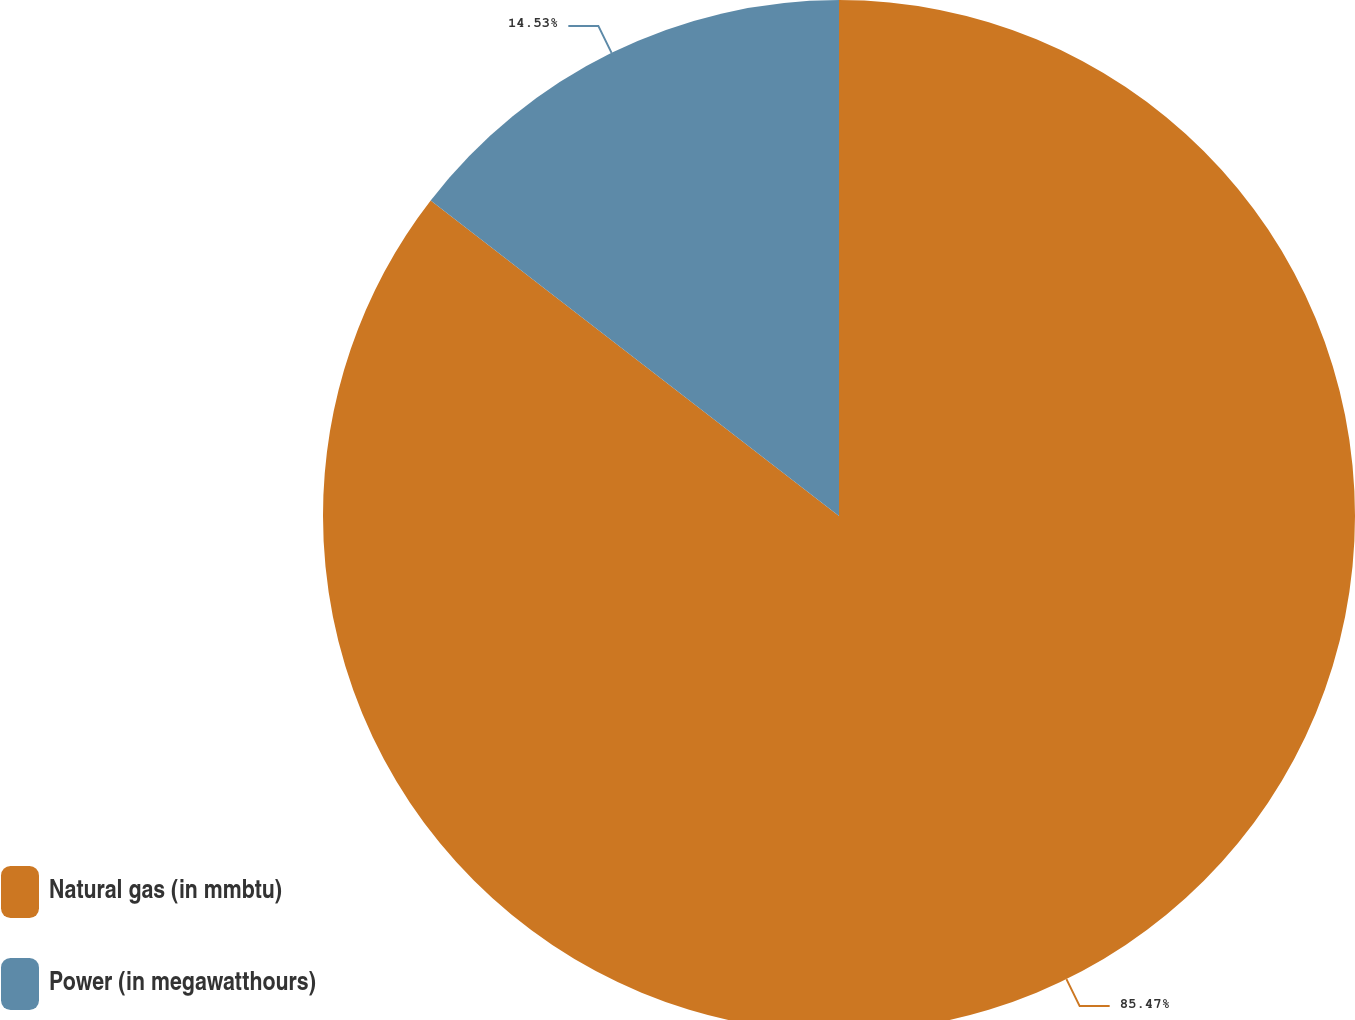Convert chart. <chart><loc_0><loc_0><loc_500><loc_500><pie_chart><fcel>Natural gas (in mmbtu)<fcel>Power (in megawatthours)<nl><fcel>85.47%<fcel>14.53%<nl></chart> 